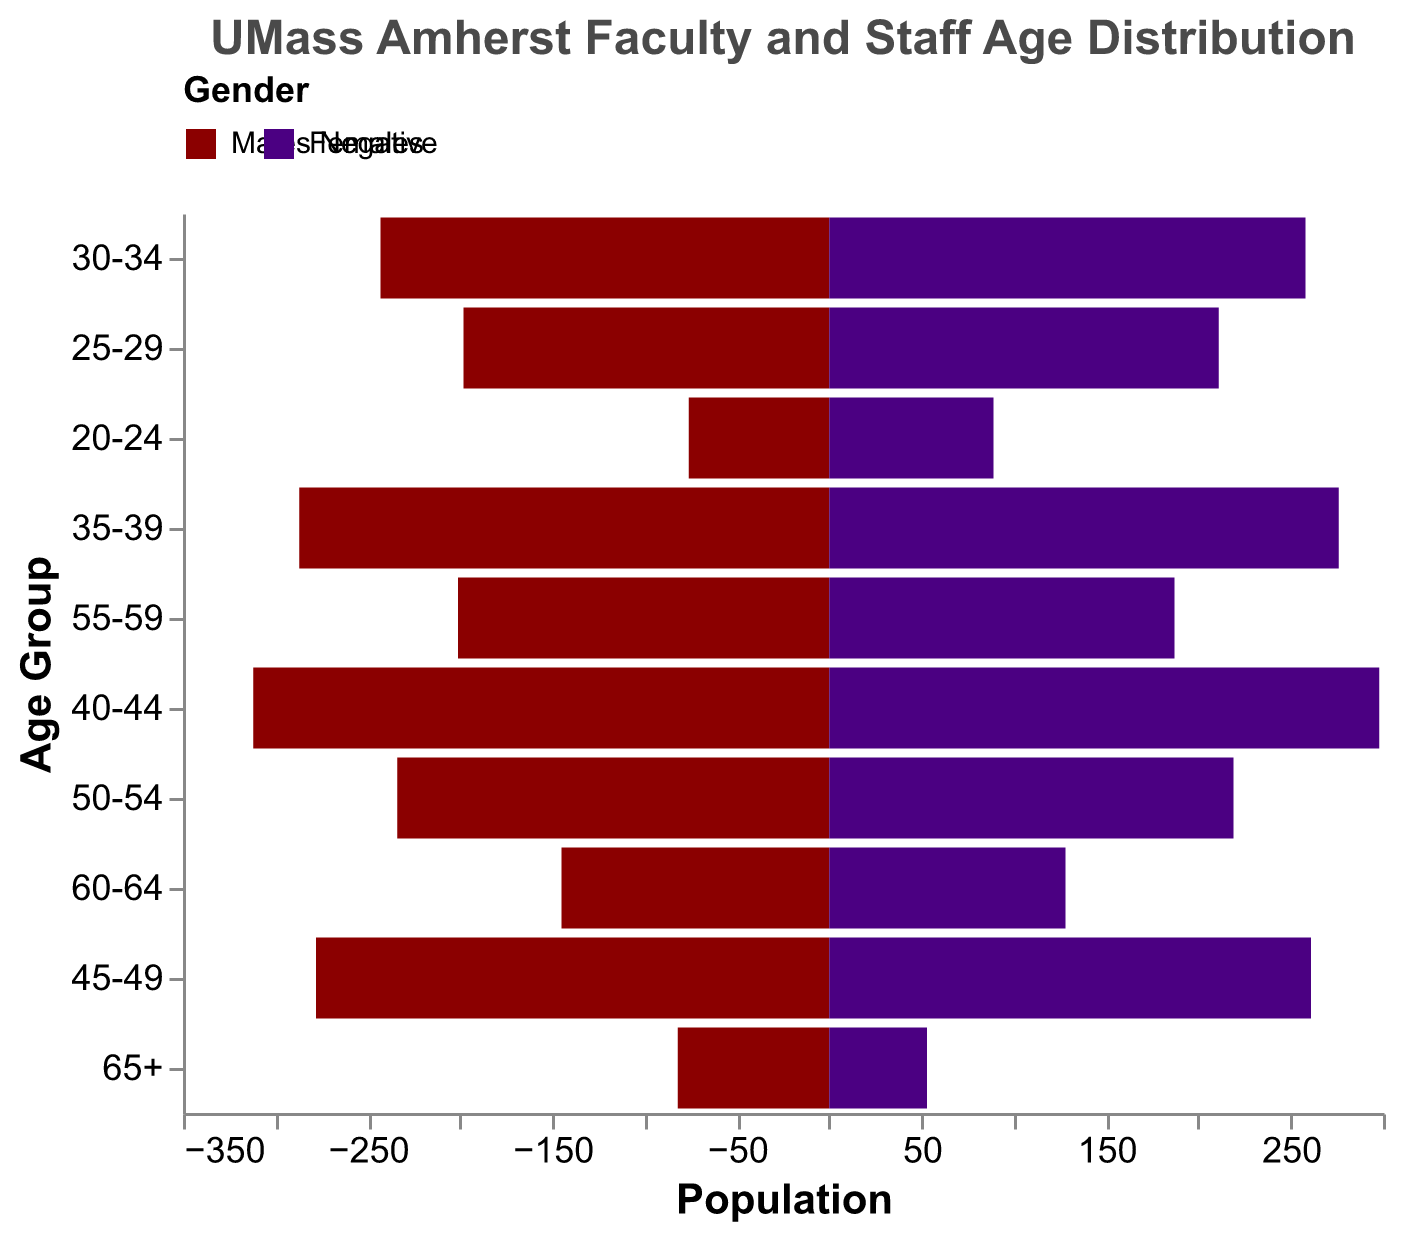What is the title of the chart? The title can be found at the top of the chart and summarizes the content of the figure. The title is "UMass Amherst Faculty and Staff Age Distribution."
Answer: UMass Amherst Faculty and Staff Age Distribution Which gender has more individuals in the age group 50-54? The figure uses bars to represent the populations of males and females for each age group. For the age group 50-54, compare the lengths of the bars for males and females. Males have a higher count indicated by a longer bar.
Answer: Males What is the total population for the age group 60-64? To get the total population for the age group 60-64, add the counts for males and females. Males: 145, Females: 128. 145 + 128 = 273.
Answer: 273 Which age group has the highest number of females? To determine the age group with the highest number of females, look at the bars representing females in each age group and find the longest one. The age group 40-44 has the longest bar for females.
Answer: 40-44 What is the difference in the population of males and females in the age group 35-39? Subtract the number of females from the number of males in the age group 35-39. Males: 287, Females: 276. 287 - 276 = 11.
Answer: 11 How does the population of males aged 25-29 compare to males aged 55-59? Compare the bar lengths for males in the age groups 25-29 and 55-59. The population of males aged 25-29 is 198, while for 55-59, it is 201. Males aged 55-59 is slightly higher than 25-29.
Answer: Males aged 55-59 is higher Which age group has the smallest overall population? To find the smallest overall population, sum the male and female counts for each age group and identify the smallest total. The age group 20-24 totals 165 (Males: 76, Females: 89), which is the smallest number.
Answer: 20-24 What is the average population of males across all age groups? Sum the male populations in all age groups: 82 + 145 + 201 + 234 + 278 + 312 + 287 + 243 + 198 + 76 = 2056. Divide by the number of age groups (10). 2056 / 10 = 205.6.
Answer: 205.6 What is the combined population of individuals aged 30-39? Add the populations of males and females for the age groups 30-34 and 35-39. Males: 243 + 287, Females: 258 + 276. Total = 243 + 287 + 258 + 276 = 1064.
Answer: 1064 